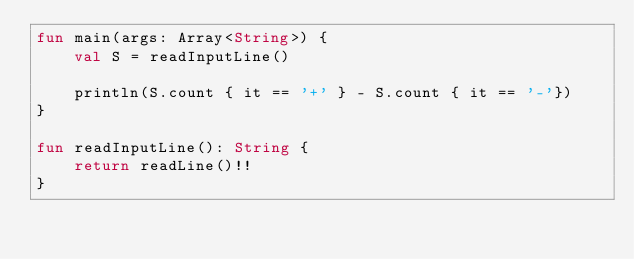<code> <loc_0><loc_0><loc_500><loc_500><_Kotlin_>fun main(args: Array<String>) {
    val S = readInputLine()

    println(S.count { it == '+' } - S.count { it == '-'})
}

fun readInputLine(): String {
    return readLine()!!
}
</code> 